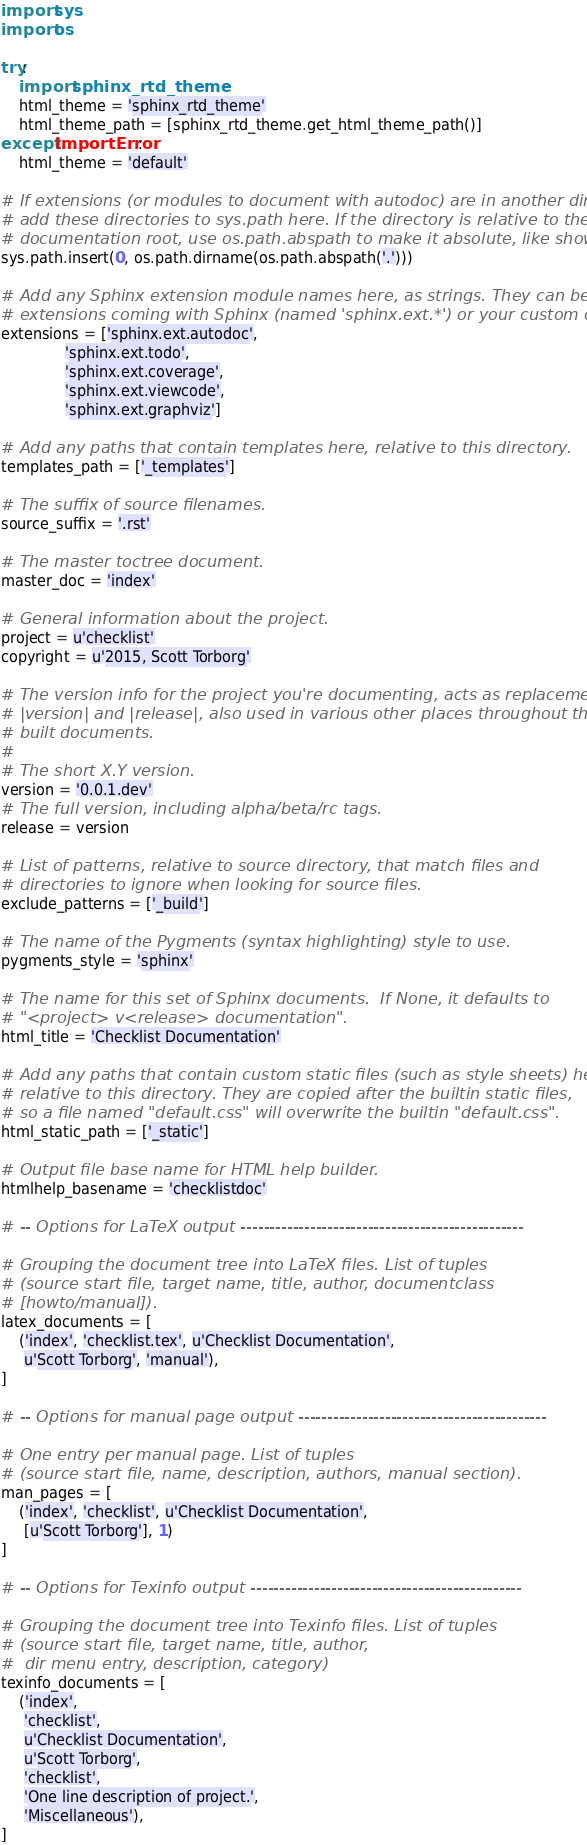Convert code to text. <code><loc_0><loc_0><loc_500><loc_500><_Python_>import sys
import os

try:
    import sphinx_rtd_theme
    html_theme = 'sphinx_rtd_theme'
    html_theme_path = [sphinx_rtd_theme.get_html_theme_path()]
except ImportError:
    html_theme = 'default'

# If extensions (or modules to document with autodoc) are in another directory,
# add these directories to sys.path here. If the directory is relative to the
# documentation root, use os.path.abspath to make it absolute, like shown here.
sys.path.insert(0, os.path.dirname(os.path.abspath('.')))

# Add any Sphinx extension module names here, as strings. They can be
# extensions coming with Sphinx (named 'sphinx.ext.*') or your custom ones.
extensions = ['sphinx.ext.autodoc',
              'sphinx.ext.todo',
              'sphinx.ext.coverage',
              'sphinx.ext.viewcode',
              'sphinx.ext.graphviz']

# Add any paths that contain templates here, relative to this directory.
templates_path = ['_templates']

# The suffix of source filenames.
source_suffix = '.rst'

# The master toctree document.
master_doc = 'index'

# General information about the project.
project = u'checklist'
copyright = u'2015, Scott Torborg'

# The version info for the project you're documenting, acts as replacement for
# |version| and |release|, also used in various other places throughout the
# built documents.
#
# The short X.Y version.
version = '0.0.1.dev'
# The full version, including alpha/beta/rc tags.
release = version

# List of patterns, relative to source directory, that match files and
# directories to ignore when looking for source files.
exclude_patterns = ['_build']

# The name of the Pygments (syntax highlighting) style to use.
pygments_style = 'sphinx'

# The name for this set of Sphinx documents.  If None, it defaults to
# "<project> v<release> documentation".
html_title = 'Checklist Documentation'

# Add any paths that contain custom static files (such as style sheets) here,
# relative to this directory. They are copied after the builtin static files,
# so a file named "default.css" will overwrite the builtin "default.css".
html_static_path = ['_static']

# Output file base name for HTML help builder.
htmlhelp_basename = 'checklistdoc'

# -- Options for LaTeX output -------------------------------------------------

# Grouping the document tree into LaTeX files. List of tuples
# (source start file, target name, title, author, documentclass
# [howto/manual]).
latex_documents = [
    ('index', 'checklist.tex', u'Checklist Documentation',
     u'Scott Torborg', 'manual'),
]

# -- Options for manual page output -------------------------------------------

# One entry per manual page. List of tuples
# (source start file, name, description, authors, manual section).
man_pages = [
    ('index', 'checklist', u'Checklist Documentation',
     [u'Scott Torborg'], 1)
]

# -- Options for Texinfo output -----------------------------------------------

# Grouping the document tree into Texinfo files. List of tuples
# (source start file, target name, title, author,
#  dir menu entry, description, category)
texinfo_documents = [
    ('index',
     'checklist',
     u'Checklist Documentation',
     u'Scott Torborg',
     'checklist',
     'One line description of project.',
     'Miscellaneous'),
]
</code> 